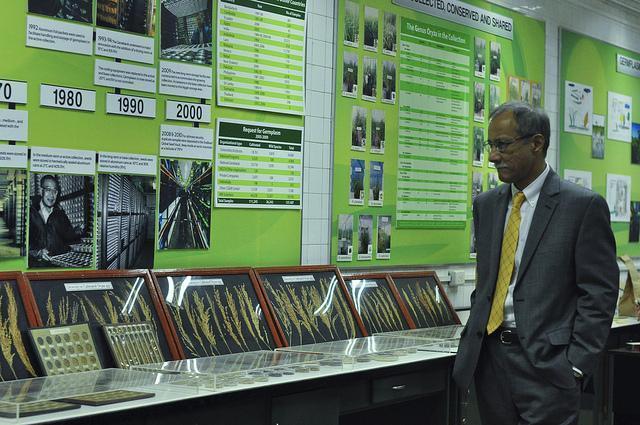How many different centuries are represented on the wall?
Give a very brief answer. 4. How many people are there?
Give a very brief answer. 2. 